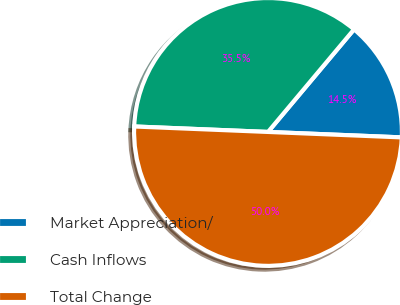Convert chart. <chart><loc_0><loc_0><loc_500><loc_500><pie_chart><fcel>Market Appreciation/<fcel>Cash Inflows<fcel>Total Change<nl><fcel>14.54%<fcel>35.46%<fcel>50.0%<nl></chart> 